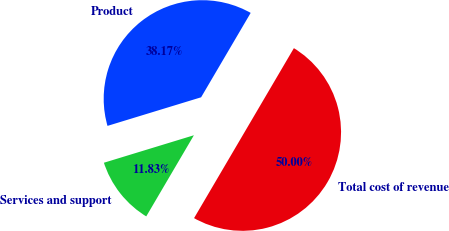<chart> <loc_0><loc_0><loc_500><loc_500><pie_chart><fcel>Product<fcel>Services and support<fcel>Total cost of revenue<nl><fcel>38.17%<fcel>11.83%<fcel>50.0%<nl></chart> 